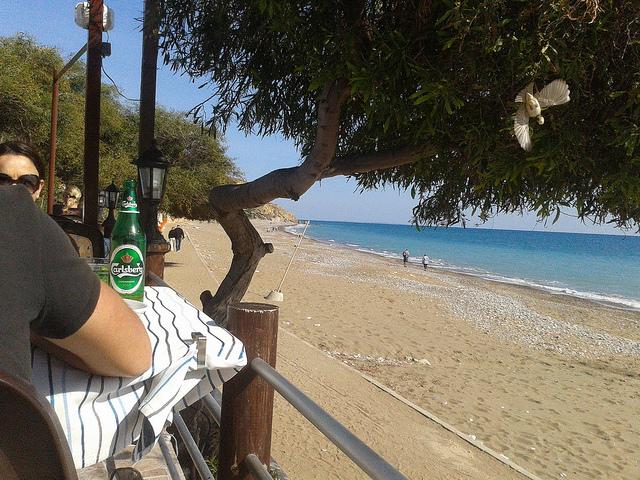What is inside the green bottle on the table? beer 